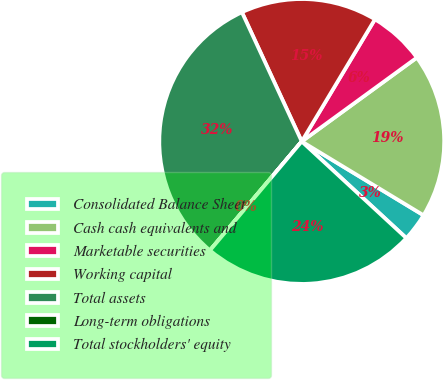Convert chart to OTSL. <chart><loc_0><loc_0><loc_500><loc_500><pie_chart><fcel>Consolidated Balance Sheet<fcel>Cash cash equivalents and<fcel>Marketable securities<fcel>Working capital<fcel>Total assets<fcel>Long-term obligations<fcel>Total stockholders' equity<nl><fcel>3.2%<fcel>18.69%<fcel>6.39%<fcel>15.49%<fcel>31.95%<fcel>0.01%<fcel>24.27%<nl></chart> 